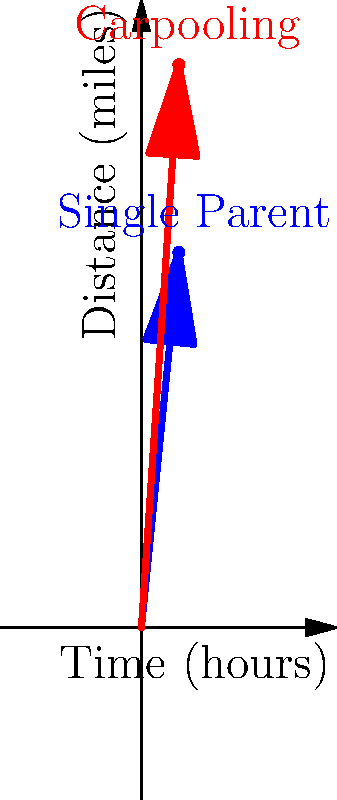A single parent typically drives 20 miles in 2 hours for their daily commute and errands. By carpooling with other single parents, they can cover 30 miles in the same time. Using vector representation, calculate how much time the single parent could save on their original 20-mile journey by carpooling. To solve this problem, we'll follow these steps:

1. Calculate the velocities:
   - Single parent: $v_1 = \frac{20 \text{ miles}}{2 \text{ hours}} = 10 \text{ mph}$
   - Carpooling: $v_2 = \frac{30 \text{ miles}}{2 \text{ hours}} = 15 \text{ mph}$

2. The original journey is 20 miles. We need to find how long it would take at the carpooling speed:
   $t = \frac{\text{distance}}{\text{velocity}} = \frac{20 \text{ miles}}{15 \text{ mph}} = \frac{4}{3} \text{ hours} = 1.33 \text{ hours}$

3. Calculate time saved:
   Time saved = Original time - Carpooling time
   $= 2 \text{ hours} - 1.33 \text{ hours} = 0.67 \text{ hours}$

4. Convert to minutes:
   $0.67 \text{ hours} \times 60 \text{ minutes/hour} = 40 \text{ minutes}$

Therefore, the single parent could save approximately 40 minutes on their original 20-mile journey by carpooling.
Answer: 40 minutes 